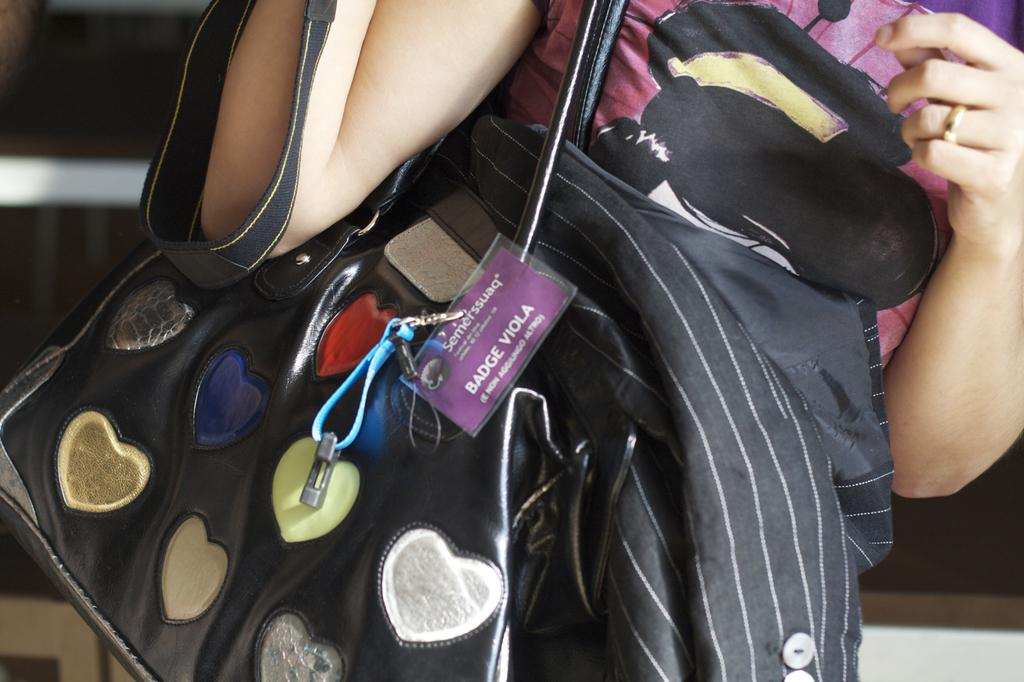What is the gender of the person in the image? The person in the image is a female. What is the female wearing in the image? The female is wearing a pink dress. Can you describe any accessories the female is carrying in the image? Yes, there is a handbag in the image. What is the color of the handbag? The handbag is black in color. Is the female collecting honey from a beehive in the wilderness in the image? No, there is no indication of honey, beehives, or wilderness in the image. 